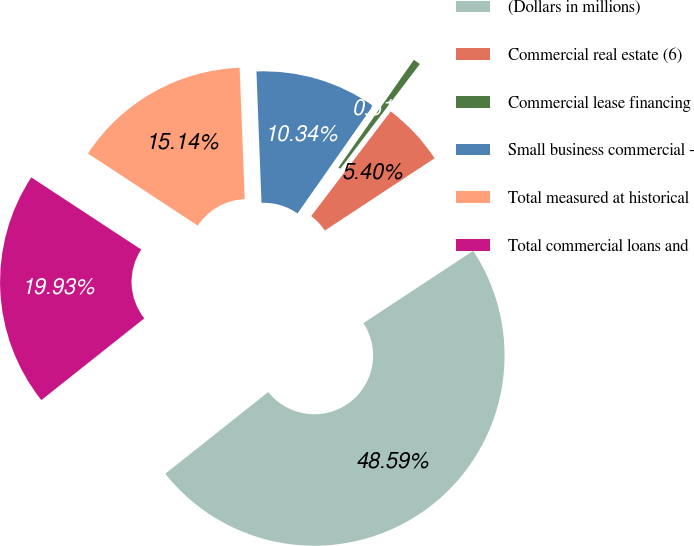Convert chart. <chart><loc_0><loc_0><loc_500><loc_500><pie_chart><fcel>(Dollars in millions)<fcel>Commercial real estate (6)<fcel>Commercial lease financing<fcel>Small business commercial -<fcel>Total measured at historical<fcel>Total commercial loans and<nl><fcel>48.59%<fcel>5.4%<fcel>0.61%<fcel>10.34%<fcel>15.14%<fcel>19.93%<nl></chart> 